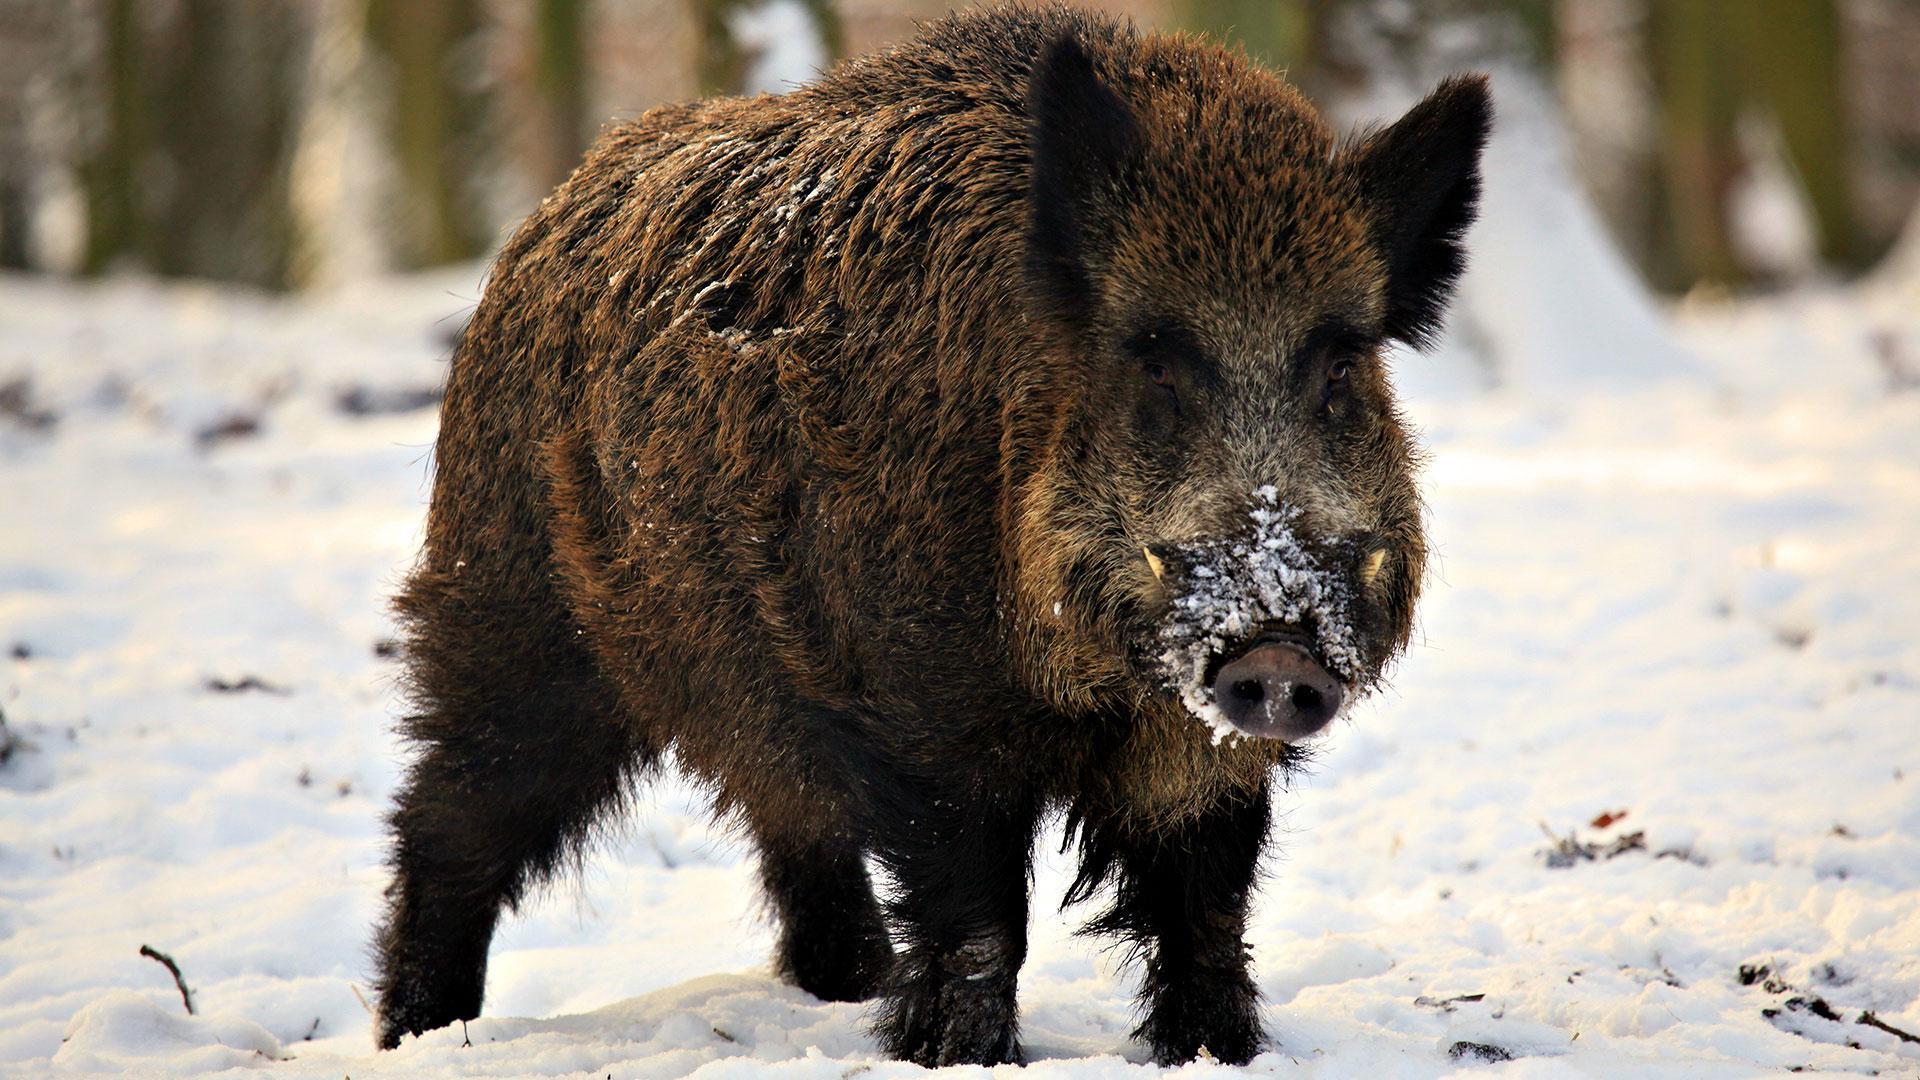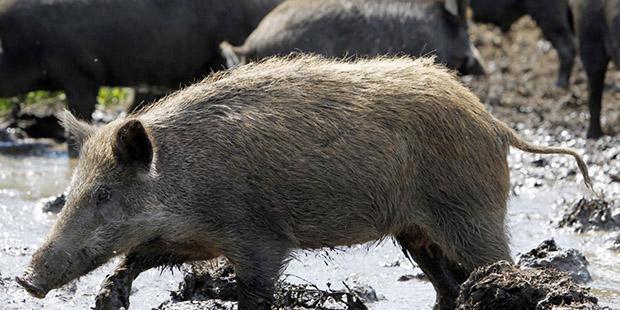The first image is the image on the left, the second image is the image on the right. For the images shown, is this caption "One of the images of the boar is identical." true? Answer yes or no. No. The first image is the image on the left, the second image is the image on the right. Evaluate the accuracy of this statement regarding the images: "In one image the ground is not covered in snow.". Is it true? Answer yes or no. No. 